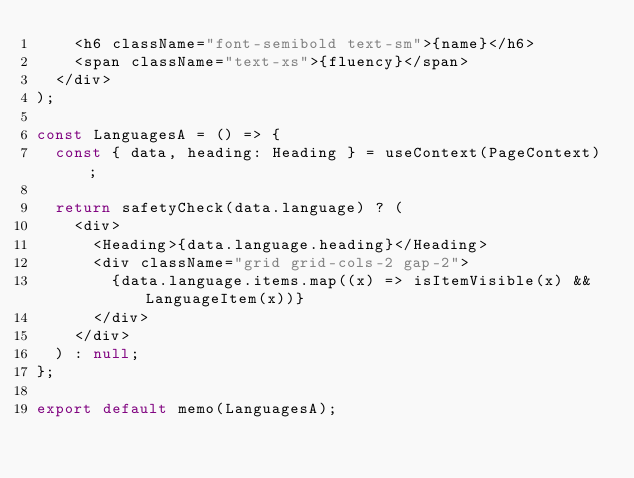Convert code to text. <code><loc_0><loc_0><loc_500><loc_500><_JavaScript_>    <h6 className="font-semibold text-sm">{name}</h6>
    <span className="text-xs">{fluency}</span>
  </div>
);

const LanguagesA = () => {
  const { data, heading: Heading } = useContext(PageContext);

  return safetyCheck(data.language) ? (
    <div>
      <Heading>{data.language.heading}</Heading>
      <div className="grid grid-cols-2 gap-2">
        {data.language.items.map((x) => isItemVisible(x) && LanguageItem(x))}
      </div>
    </div>
  ) : null;
};

export default memo(LanguagesA);
</code> 